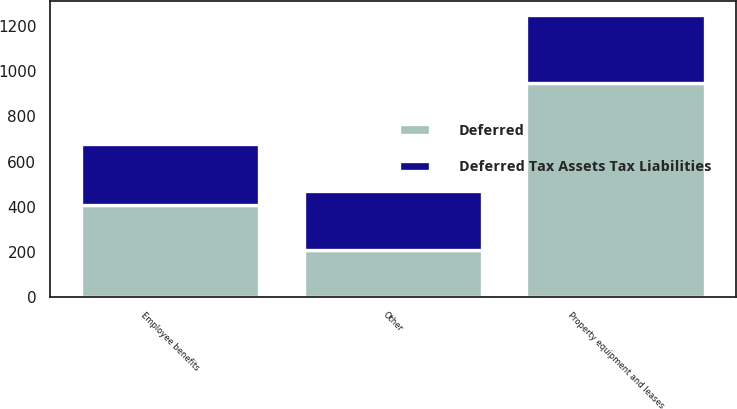<chart> <loc_0><loc_0><loc_500><loc_500><stacked_bar_chart><ecel><fcel>Property equipment and leases<fcel>Employee benefits<fcel>Other<nl><fcel>Deferred Tax Assets Tax Liabilities<fcel>303<fcel>270<fcel>262<nl><fcel>Deferred<fcel>946<fcel>407<fcel>207<nl></chart> 